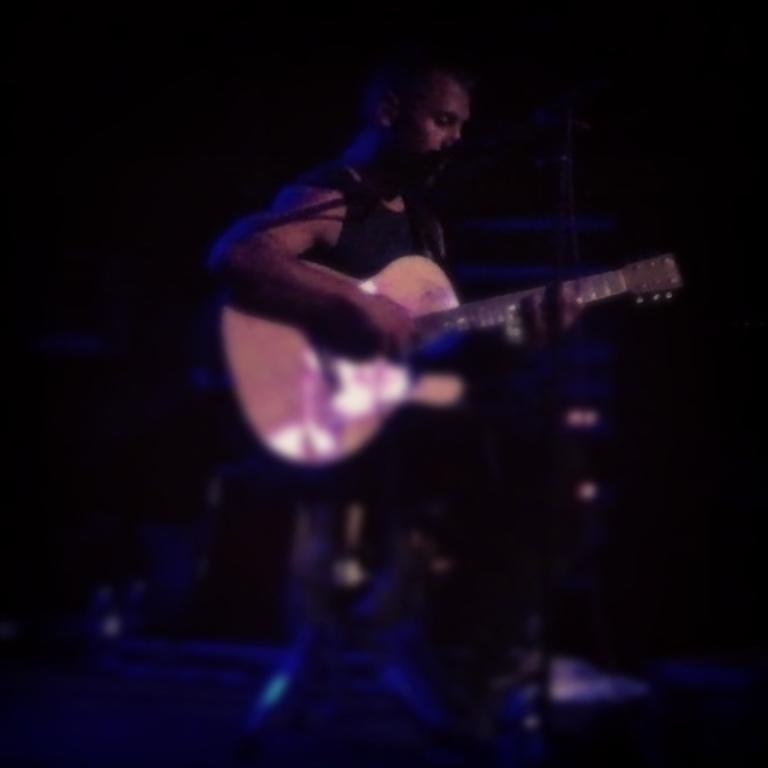What is the main subject of the image? There is a person in the image. What is the person doing in the image? The person is playing a guitar. What type of kite is the person flying in the image? There is no kite present in the image; the person is playing a guitar. What property does the person own in the image? There is no information about the person's property in the image; it only shows the person playing a guitar. 